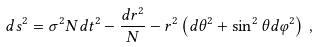Convert formula to latex. <formula><loc_0><loc_0><loc_500><loc_500>d s ^ { 2 } = \sigma ^ { 2 } N d t ^ { 2 } - \frac { d r ^ { 2 } } { N } - r ^ { 2 } \left ( d \theta ^ { 2 } + \sin ^ { 2 } \theta d \varphi ^ { 2 } \right ) \, ,</formula> 